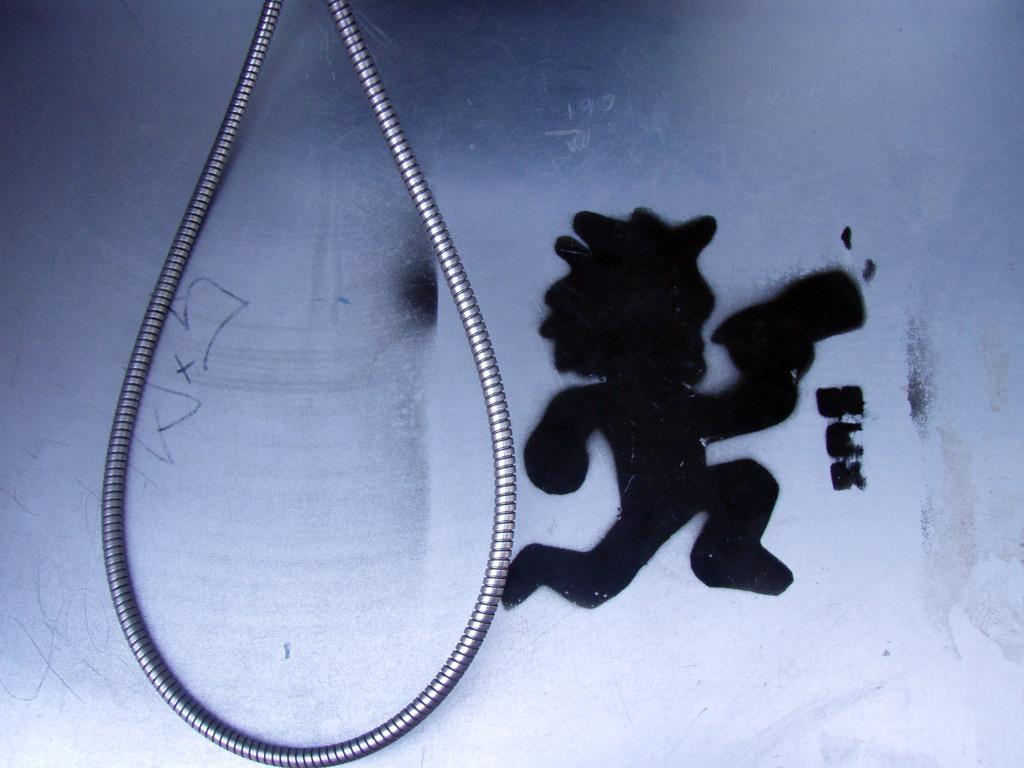What can be seen on the right side of the image? There is graffiti on the right side of the image. What is located on the left side of the image? There is a steel rope on the left side of the image. Is there any steam visible in the image? There is no steam present in the image. Can you see a stream in the image? There is no stream present in the image. 